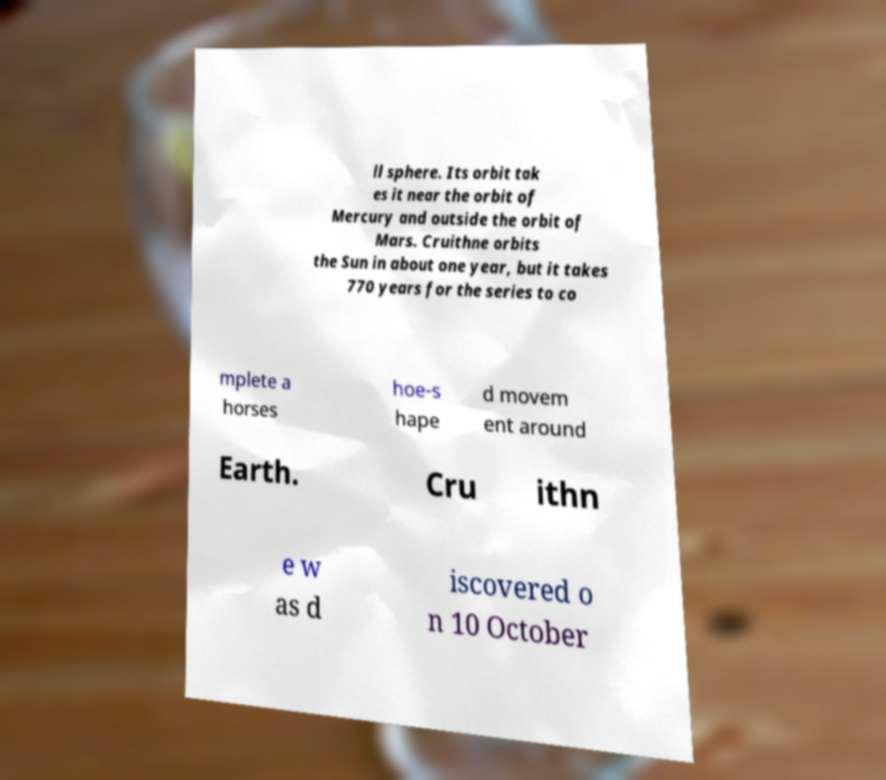Please read and relay the text visible in this image. What does it say? ll sphere. Its orbit tak es it near the orbit of Mercury and outside the orbit of Mars. Cruithne orbits the Sun in about one year, but it takes 770 years for the series to co mplete a horses hoe-s hape d movem ent around Earth. Cru ithn e w as d iscovered o n 10 October 